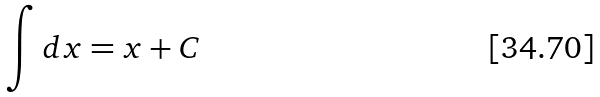<formula> <loc_0><loc_0><loc_500><loc_500>\int d x = x + C</formula> 